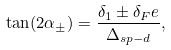Convert formula to latex. <formula><loc_0><loc_0><loc_500><loc_500>\tan ( 2 \alpha _ { \pm } ) = \frac { \delta _ { 1 } \pm \delta _ { F } e } { \Delta _ { s p - d } } ,</formula> 